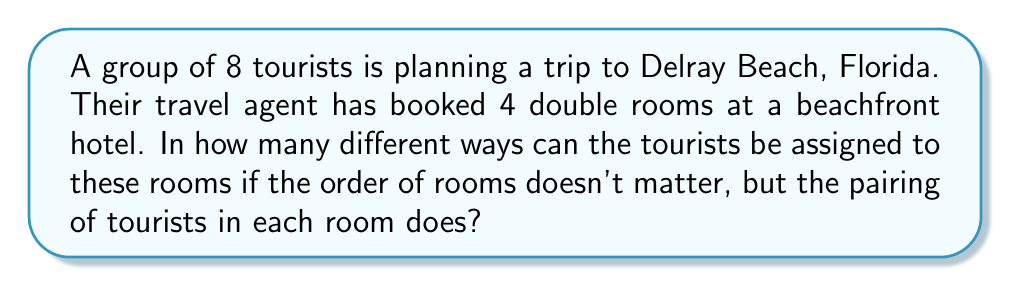Can you solve this math problem? Let's approach this step-by-step:

1) First, we need to understand that this is a combination problem, not a permutation, because the order of rooms doesn't matter.

2) We can think of this as dividing 8 people into 4 groups of 2.

3) The formula for this type of problem is:

   $$\frac{8!}{(2!)^4 \cdot 4!}$$

4) Let's break down why:
   - 8! represents all possible arrangements of 8 people
   - (2!)^4 in the denominator accounts for the internal arrangement of each pair in the 4 rooms
   - 4! in the denominator accounts for the fact that the order of rooms doesn't matter

5) Now, let's calculate:

   $$\frac{8!}{(2!)^4 \cdot 4!} = \frac{40320}{(2 \cdot 2 \cdot 2 \cdot 2) \cdot 24} = \frac{40320}{16 \cdot 24} = \frac{40320}{384} = 105$$

Therefore, there are 105 different ways to assign the tourists to the rooms.
Answer: 105 